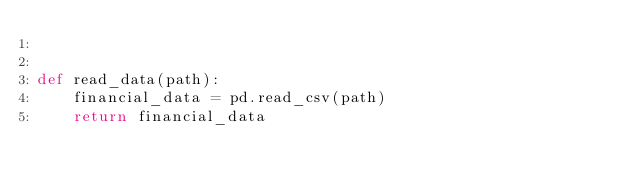Convert code to text. <code><loc_0><loc_0><loc_500><loc_500><_Python_>

def read_data(path):
    financial_data = pd.read_csv(path)
    return financial_data


</code> 